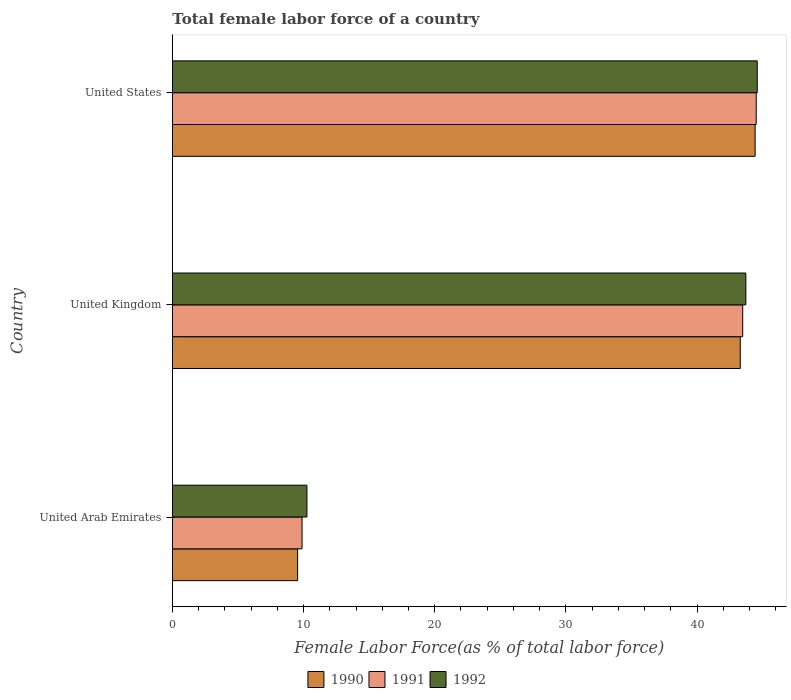Are the number of bars on each tick of the Y-axis equal?
Provide a succinct answer. Yes. What is the label of the 2nd group of bars from the top?
Your answer should be compact. United Kingdom. What is the percentage of female labor force in 1991 in United Kingdom?
Give a very brief answer. 43.48. Across all countries, what is the maximum percentage of female labor force in 1990?
Your answer should be very brief. 44.42. Across all countries, what is the minimum percentage of female labor force in 1992?
Your answer should be very brief. 10.26. In which country was the percentage of female labor force in 1992 maximum?
Your response must be concise. United States. In which country was the percentage of female labor force in 1992 minimum?
Provide a succinct answer. United Arab Emirates. What is the total percentage of female labor force in 1991 in the graph?
Keep it short and to the point. 97.86. What is the difference between the percentage of female labor force in 1990 in United Arab Emirates and that in United States?
Ensure brevity in your answer.  -34.87. What is the difference between the percentage of female labor force in 1992 in United Kingdom and the percentage of female labor force in 1991 in United States?
Make the answer very short. -0.79. What is the average percentage of female labor force in 1991 per country?
Make the answer very short. 32.62. What is the difference between the percentage of female labor force in 1992 and percentage of female labor force in 1990 in United Kingdom?
Give a very brief answer. 0.43. What is the ratio of the percentage of female labor force in 1990 in United Arab Emirates to that in United States?
Offer a very short reply. 0.21. Is the percentage of female labor force in 1992 in United Arab Emirates less than that in United States?
Your answer should be very brief. Yes. What is the difference between the highest and the second highest percentage of female labor force in 1992?
Provide a short and direct response. 0.87. What is the difference between the highest and the lowest percentage of female labor force in 1992?
Your response must be concise. 34.32. In how many countries, is the percentage of female labor force in 1992 greater than the average percentage of female labor force in 1992 taken over all countries?
Provide a short and direct response. 2. Is the sum of the percentage of female labor force in 1992 in United Kingdom and United States greater than the maximum percentage of female labor force in 1991 across all countries?
Your answer should be very brief. Yes. What does the 3rd bar from the top in United Arab Emirates represents?
Make the answer very short. 1990. What does the 2nd bar from the bottom in United Arab Emirates represents?
Provide a succinct answer. 1991. Is it the case that in every country, the sum of the percentage of female labor force in 1992 and percentage of female labor force in 1991 is greater than the percentage of female labor force in 1990?
Provide a succinct answer. Yes. Are all the bars in the graph horizontal?
Offer a very short reply. Yes. How many countries are there in the graph?
Your response must be concise. 3. What is the difference between two consecutive major ticks on the X-axis?
Make the answer very short. 10. Where does the legend appear in the graph?
Make the answer very short. Bottom center. How many legend labels are there?
Give a very brief answer. 3. What is the title of the graph?
Keep it short and to the point. Total female labor force of a country. Does "2003" appear as one of the legend labels in the graph?
Provide a short and direct response. No. What is the label or title of the X-axis?
Offer a very short reply. Female Labor Force(as % of total labor force). What is the label or title of the Y-axis?
Your answer should be compact. Country. What is the Female Labor Force(as % of total labor force) in 1990 in United Arab Emirates?
Make the answer very short. 9.55. What is the Female Labor Force(as % of total labor force) of 1991 in United Arab Emirates?
Provide a short and direct response. 9.89. What is the Female Labor Force(as % of total labor force) in 1992 in United Arab Emirates?
Provide a succinct answer. 10.26. What is the Female Labor Force(as % of total labor force) in 1990 in United Kingdom?
Provide a short and direct response. 43.29. What is the Female Labor Force(as % of total labor force) in 1991 in United Kingdom?
Your answer should be very brief. 43.48. What is the Female Labor Force(as % of total labor force) of 1992 in United Kingdom?
Your answer should be very brief. 43.72. What is the Female Labor Force(as % of total labor force) in 1990 in United States?
Offer a very short reply. 44.42. What is the Female Labor Force(as % of total labor force) of 1991 in United States?
Keep it short and to the point. 44.5. What is the Female Labor Force(as % of total labor force) of 1992 in United States?
Provide a short and direct response. 44.58. Across all countries, what is the maximum Female Labor Force(as % of total labor force) of 1990?
Offer a very short reply. 44.42. Across all countries, what is the maximum Female Labor Force(as % of total labor force) in 1991?
Provide a succinct answer. 44.5. Across all countries, what is the maximum Female Labor Force(as % of total labor force) in 1992?
Your answer should be compact. 44.58. Across all countries, what is the minimum Female Labor Force(as % of total labor force) of 1990?
Your response must be concise. 9.55. Across all countries, what is the minimum Female Labor Force(as % of total labor force) of 1991?
Your answer should be compact. 9.89. Across all countries, what is the minimum Female Labor Force(as % of total labor force) in 1992?
Your answer should be very brief. 10.26. What is the total Female Labor Force(as % of total labor force) of 1990 in the graph?
Provide a short and direct response. 97.26. What is the total Female Labor Force(as % of total labor force) in 1991 in the graph?
Ensure brevity in your answer.  97.86. What is the total Female Labor Force(as % of total labor force) of 1992 in the graph?
Your answer should be very brief. 98.56. What is the difference between the Female Labor Force(as % of total labor force) in 1990 in United Arab Emirates and that in United Kingdom?
Your answer should be very brief. -33.74. What is the difference between the Female Labor Force(as % of total labor force) in 1991 in United Arab Emirates and that in United Kingdom?
Provide a short and direct response. -33.59. What is the difference between the Female Labor Force(as % of total labor force) of 1992 in United Arab Emirates and that in United Kingdom?
Offer a terse response. -33.46. What is the difference between the Female Labor Force(as % of total labor force) of 1990 in United Arab Emirates and that in United States?
Keep it short and to the point. -34.87. What is the difference between the Female Labor Force(as % of total labor force) of 1991 in United Arab Emirates and that in United States?
Offer a terse response. -34.62. What is the difference between the Female Labor Force(as % of total labor force) of 1992 in United Arab Emirates and that in United States?
Make the answer very short. -34.32. What is the difference between the Female Labor Force(as % of total labor force) in 1990 in United Kingdom and that in United States?
Give a very brief answer. -1.13. What is the difference between the Female Labor Force(as % of total labor force) in 1991 in United Kingdom and that in United States?
Keep it short and to the point. -1.03. What is the difference between the Female Labor Force(as % of total labor force) of 1992 in United Kingdom and that in United States?
Offer a terse response. -0.87. What is the difference between the Female Labor Force(as % of total labor force) in 1990 in United Arab Emirates and the Female Labor Force(as % of total labor force) in 1991 in United Kingdom?
Make the answer very short. -33.93. What is the difference between the Female Labor Force(as % of total labor force) in 1990 in United Arab Emirates and the Female Labor Force(as % of total labor force) in 1992 in United Kingdom?
Your response must be concise. -34.17. What is the difference between the Female Labor Force(as % of total labor force) in 1991 in United Arab Emirates and the Female Labor Force(as % of total labor force) in 1992 in United Kingdom?
Give a very brief answer. -33.83. What is the difference between the Female Labor Force(as % of total labor force) in 1990 in United Arab Emirates and the Female Labor Force(as % of total labor force) in 1991 in United States?
Keep it short and to the point. -34.95. What is the difference between the Female Labor Force(as % of total labor force) of 1990 in United Arab Emirates and the Female Labor Force(as % of total labor force) of 1992 in United States?
Your answer should be compact. -35.03. What is the difference between the Female Labor Force(as % of total labor force) in 1991 in United Arab Emirates and the Female Labor Force(as % of total labor force) in 1992 in United States?
Provide a succinct answer. -34.7. What is the difference between the Female Labor Force(as % of total labor force) of 1990 in United Kingdom and the Female Labor Force(as % of total labor force) of 1991 in United States?
Provide a short and direct response. -1.22. What is the difference between the Female Labor Force(as % of total labor force) of 1990 in United Kingdom and the Female Labor Force(as % of total labor force) of 1992 in United States?
Give a very brief answer. -1.29. What is the difference between the Female Labor Force(as % of total labor force) in 1991 in United Kingdom and the Female Labor Force(as % of total labor force) in 1992 in United States?
Offer a terse response. -1.11. What is the average Female Labor Force(as % of total labor force) in 1990 per country?
Provide a short and direct response. 32.42. What is the average Female Labor Force(as % of total labor force) of 1991 per country?
Provide a short and direct response. 32.62. What is the average Female Labor Force(as % of total labor force) in 1992 per country?
Your response must be concise. 32.85. What is the difference between the Female Labor Force(as % of total labor force) of 1990 and Female Labor Force(as % of total labor force) of 1991 in United Arab Emirates?
Your response must be concise. -0.34. What is the difference between the Female Labor Force(as % of total labor force) of 1990 and Female Labor Force(as % of total labor force) of 1992 in United Arab Emirates?
Provide a succinct answer. -0.71. What is the difference between the Female Labor Force(as % of total labor force) in 1991 and Female Labor Force(as % of total labor force) in 1992 in United Arab Emirates?
Provide a succinct answer. -0.37. What is the difference between the Female Labor Force(as % of total labor force) of 1990 and Female Labor Force(as % of total labor force) of 1991 in United Kingdom?
Your answer should be very brief. -0.19. What is the difference between the Female Labor Force(as % of total labor force) in 1990 and Female Labor Force(as % of total labor force) in 1992 in United Kingdom?
Make the answer very short. -0.43. What is the difference between the Female Labor Force(as % of total labor force) in 1991 and Female Labor Force(as % of total labor force) in 1992 in United Kingdom?
Offer a very short reply. -0.24. What is the difference between the Female Labor Force(as % of total labor force) in 1990 and Female Labor Force(as % of total labor force) in 1991 in United States?
Give a very brief answer. -0.08. What is the difference between the Female Labor Force(as % of total labor force) of 1990 and Female Labor Force(as % of total labor force) of 1992 in United States?
Offer a very short reply. -0.16. What is the difference between the Female Labor Force(as % of total labor force) of 1991 and Female Labor Force(as % of total labor force) of 1992 in United States?
Keep it short and to the point. -0.08. What is the ratio of the Female Labor Force(as % of total labor force) in 1990 in United Arab Emirates to that in United Kingdom?
Your answer should be compact. 0.22. What is the ratio of the Female Labor Force(as % of total labor force) of 1991 in United Arab Emirates to that in United Kingdom?
Provide a short and direct response. 0.23. What is the ratio of the Female Labor Force(as % of total labor force) in 1992 in United Arab Emirates to that in United Kingdom?
Your response must be concise. 0.23. What is the ratio of the Female Labor Force(as % of total labor force) in 1990 in United Arab Emirates to that in United States?
Your answer should be compact. 0.21. What is the ratio of the Female Labor Force(as % of total labor force) in 1991 in United Arab Emirates to that in United States?
Offer a terse response. 0.22. What is the ratio of the Female Labor Force(as % of total labor force) of 1992 in United Arab Emirates to that in United States?
Your answer should be very brief. 0.23. What is the ratio of the Female Labor Force(as % of total labor force) in 1990 in United Kingdom to that in United States?
Give a very brief answer. 0.97. What is the ratio of the Female Labor Force(as % of total labor force) of 1991 in United Kingdom to that in United States?
Provide a short and direct response. 0.98. What is the ratio of the Female Labor Force(as % of total labor force) of 1992 in United Kingdom to that in United States?
Provide a succinct answer. 0.98. What is the difference between the highest and the second highest Female Labor Force(as % of total labor force) in 1990?
Your answer should be compact. 1.13. What is the difference between the highest and the second highest Female Labor Force(as % of total labor force) in 1991?
Give a very brief answer. 1.03. What is the difference between the highest and the second highest Female Labor Force(as % of total labor force) in 1992?
Provide a short and direct response. 0.87. What is the difference between the highest and the lowest Female Labor Force(as % of total labor force) of 1990?
Ensure brevity in your answer.  34.87. What is the difference between the highest and the lowest Female Labor Force(as % of total labor force) in 1991?
Your answer should be very brief. 34.62. What is the difference between the highest and the lowest Female Labor Force(as % of total labor force) in 1992?
Offer a terse response. 34.32. 